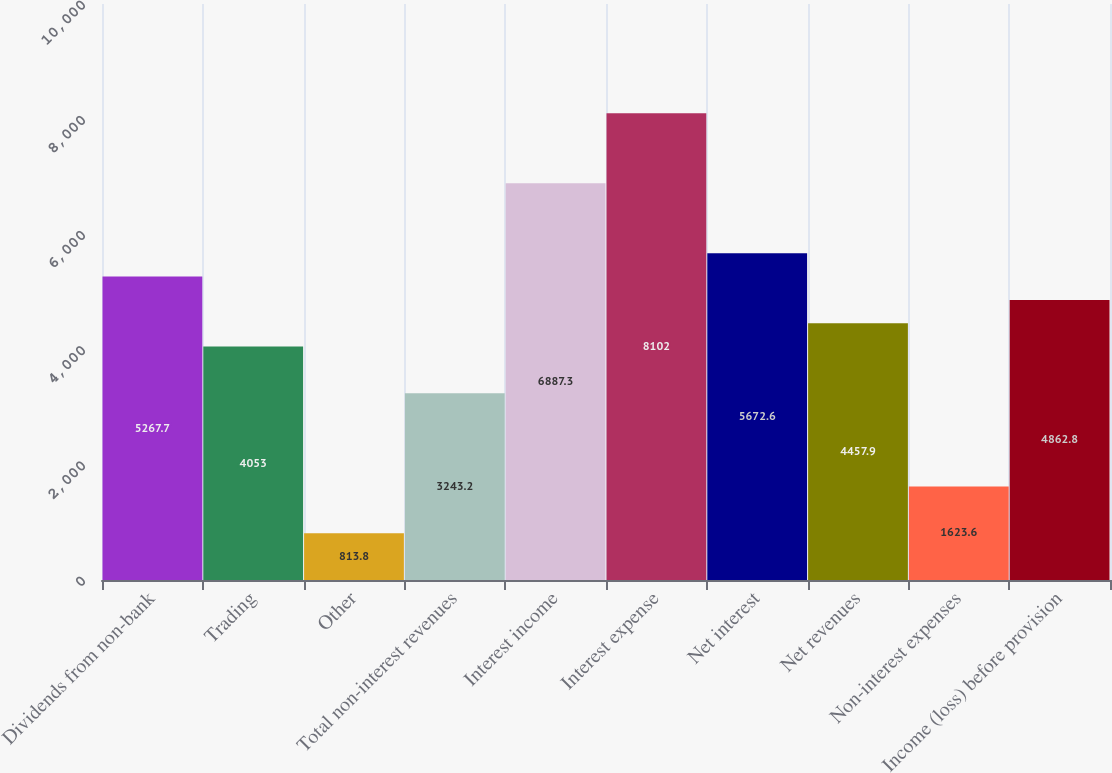<chart> <loc_0><loc_0><loc_500><loc_500><bar_chart><fcel>Dividends from non-bank<fcel>Trading<fcel>Other<fcel>Total non-interest revenues<fcel>Interest income<fcel>Interest expense<fcel>Net interest<fcel>Net revenues<fcel>Non-interest expenses<fcel>Income (loss) before provision<nl><fcel>5267.7<fcel>4053<fcel>813.8<fcel>3243.2<fcel>6887.3<fcel>8102<fcel>5672.6<fcel>4457.9<fcel>1623.6<fcel>4862.8<nl></chart> 